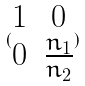<formula> <loc_0><loc_0><loc_500><loc_500>( \begin{matrix} 1 & 0 \\ 0 & \frac { n _ { 1 } } { n _ { 2 } } \end{matrix} )</formula> 